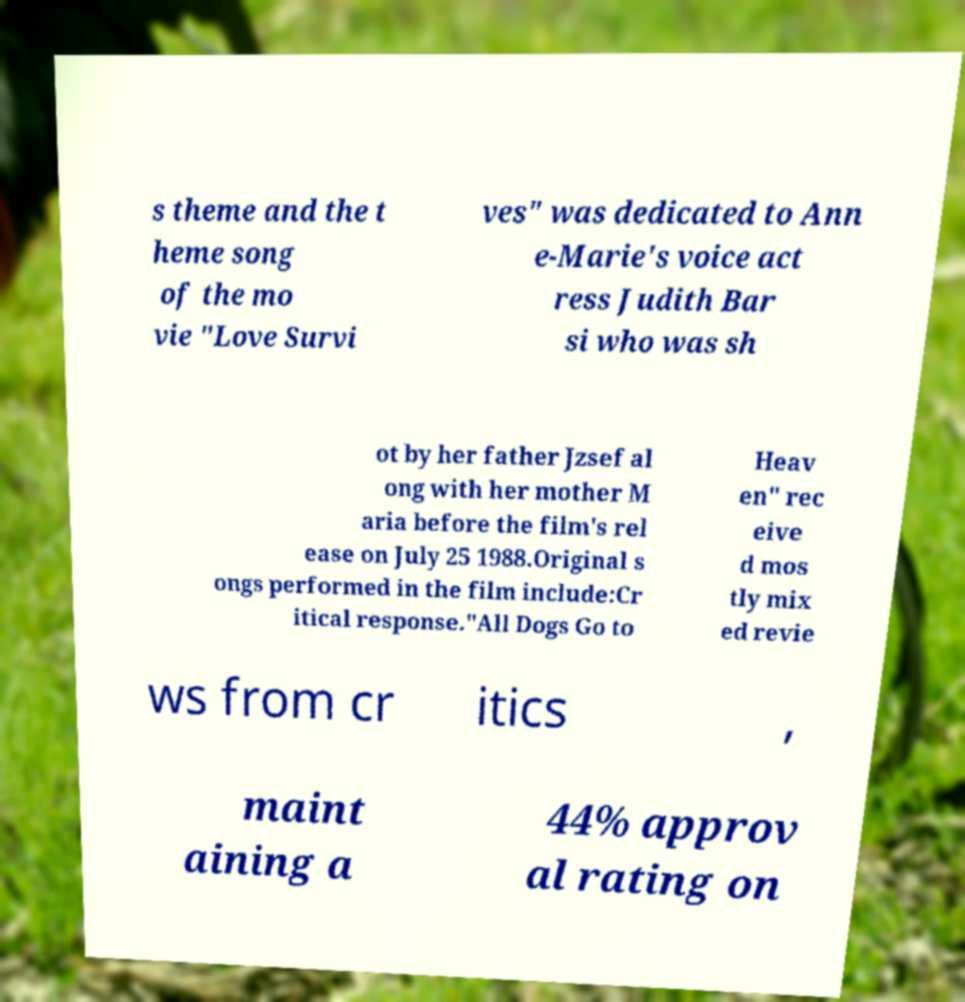Please identify and transcribe the text found in this image. s theme and the t heme song of the mo vie "Love Survi ves" was dedicated to Ann e-Marie's voice act ress Judith Bar si who was sh ot by her father Jzsef al ong with her mother M aria before the film's rel ease on July 25 1988.Original s ongs performed in the film include:Cr itical response."All Dogs Go to Heav en" rec eive d mos tly mix ed revie ws from cr itics , maint aining a 44% approv al rating on 